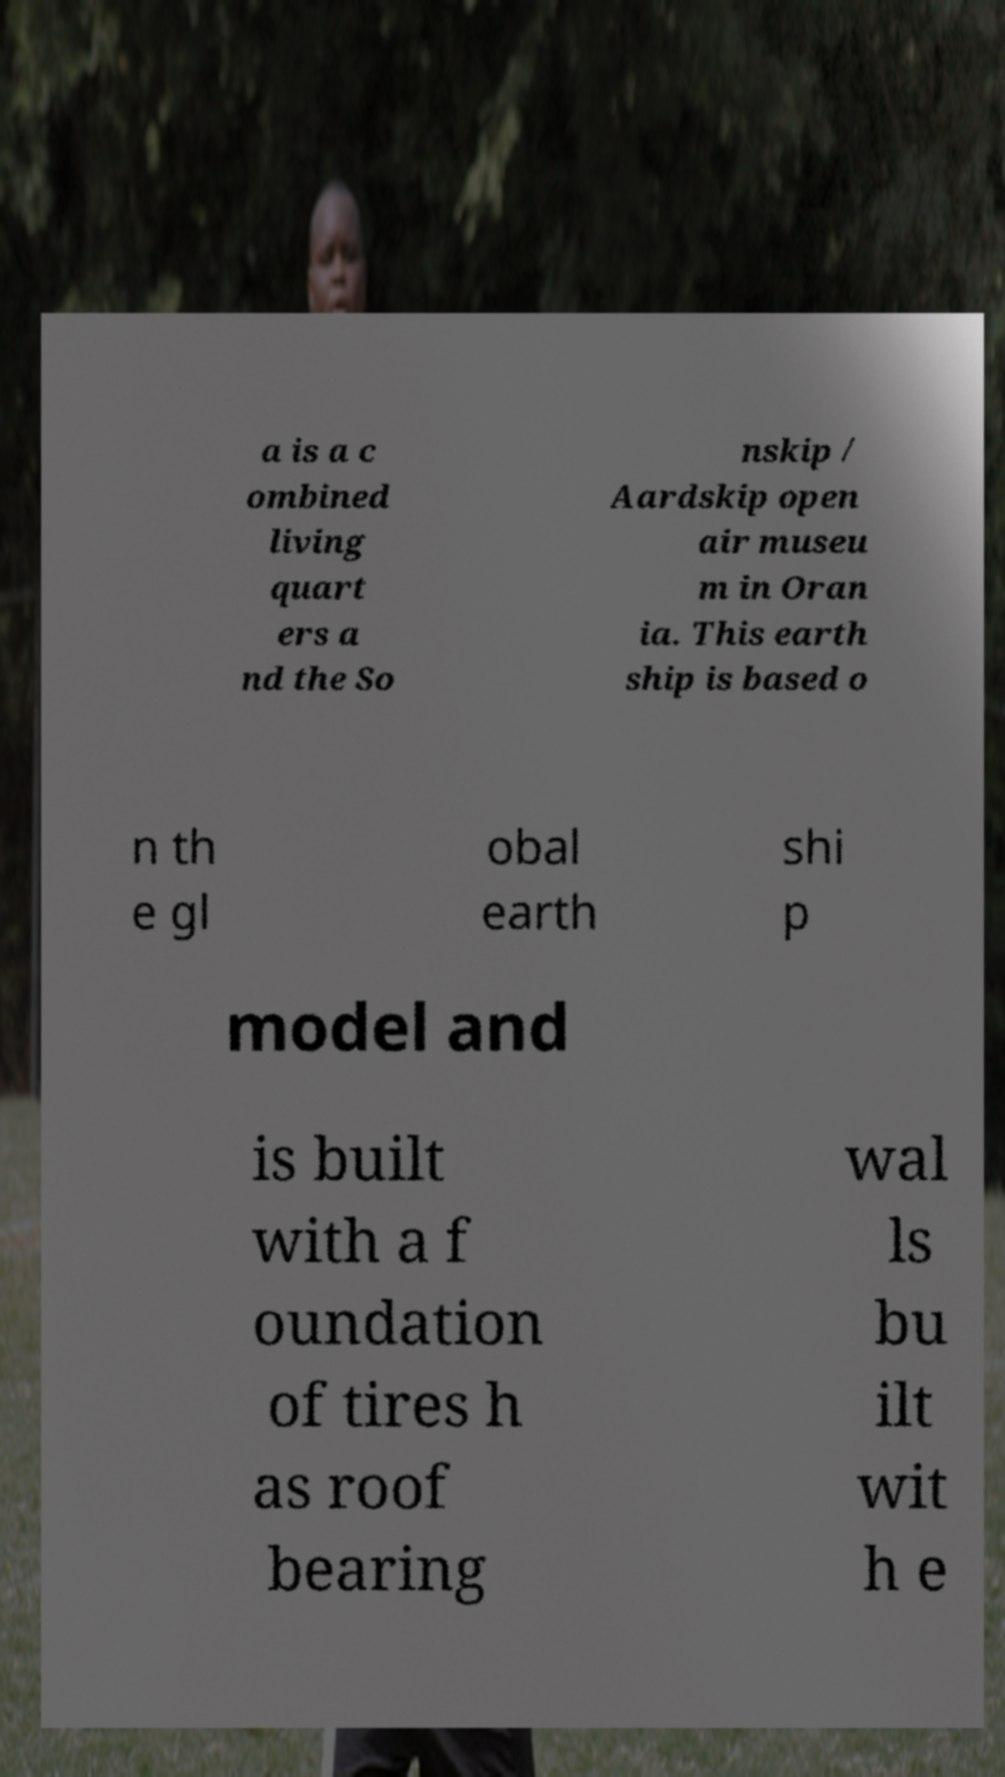Can you accurately transcribe the text from the provided image for me? a is a c ombined living quart ers a nd the So nskip / Aardskip open air museu m in Oran ia. This earth ship is based o n th e gl obal earth shi p model and is built with a f oundation of tires h as roof bearing wal ls bu ilt wit h e 